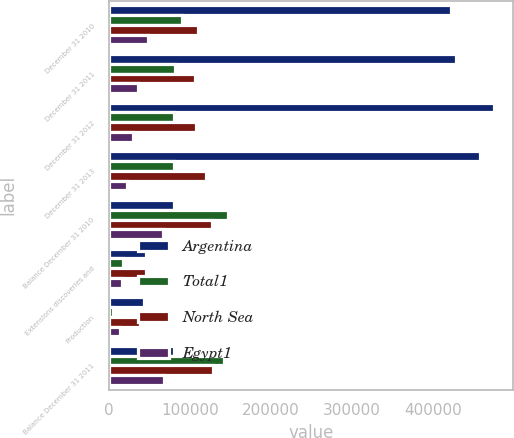Convert chart. <chart><loc_0><loc_0><loc_500><loc_500><stacked_bar_chart><ecel><fcel>December 31 2010<fcel>December 31 2011<fcel>December 31 2012<fcel>December 31 2013<fcel>Balance December 31 2010<fcel>Extensions discoveries and<fcel>Production<fcel>Balance December 31 2011<nl><fcel>Argentina<fcel>422737<fcel>428251<fcel>474837<fcel>457981<fcel>80110.5<fcel>45676<fcel>43587<fcel>80110.5<nl><fcel>Total1<fcel>90292<fcel>81846<fcel>79695<fcel>80526<fcel>147146<fcel>16712<fcel>5202<fcel>141591<nl><fcel>North Sea<fcel>109657<fcel>105840<fcel>106746<fcel>119242<fcel>127127<fcel>45021<fcel>37928<fcel>128035<nl><fcel>Egypt1<fcel>48072<fcel>35725<fcel>29053<fcel>22524<fcel>66136<fcel>15762<fcel>13953<fcel>67945<nl></chart> 